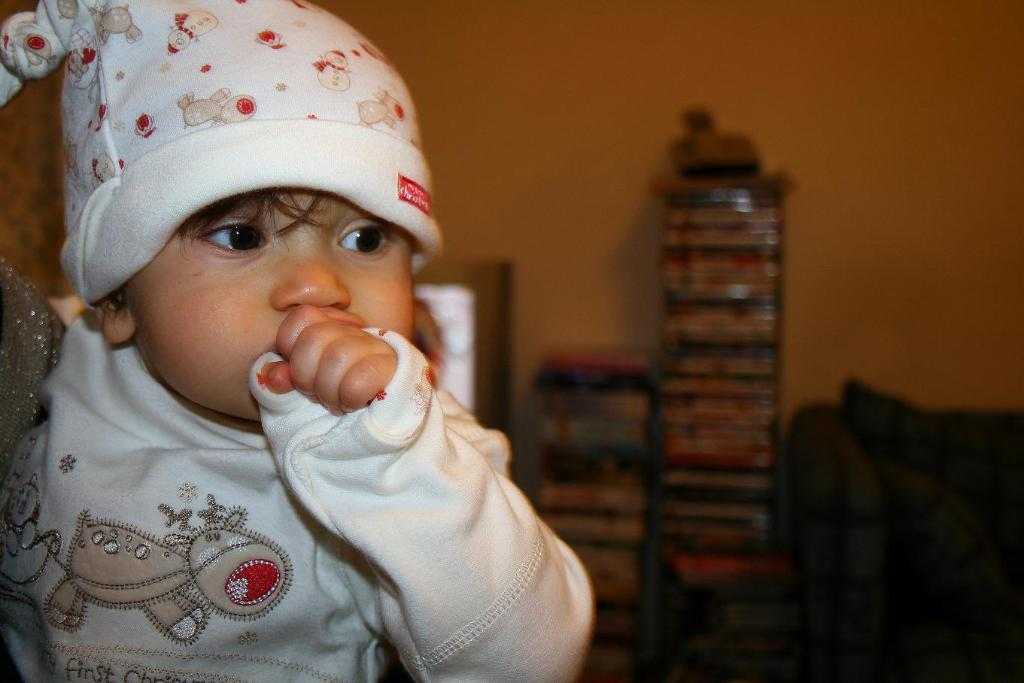What is the main subject of the image? The main subject of the image is a small kid. What is the kid wearing? The kid is wearing a white dress and a white cap. What can be seen in the background of the image? There are books in the background of the image. What piece of furniture is visible to the right of the image? There is a sofa to the right of the image. What example of silverware can be seen in the image? There is no silverware present in the image. How many hands are visible in the image? The image does not show any hands, as it primarily features the small kid and the surrounding environment. 